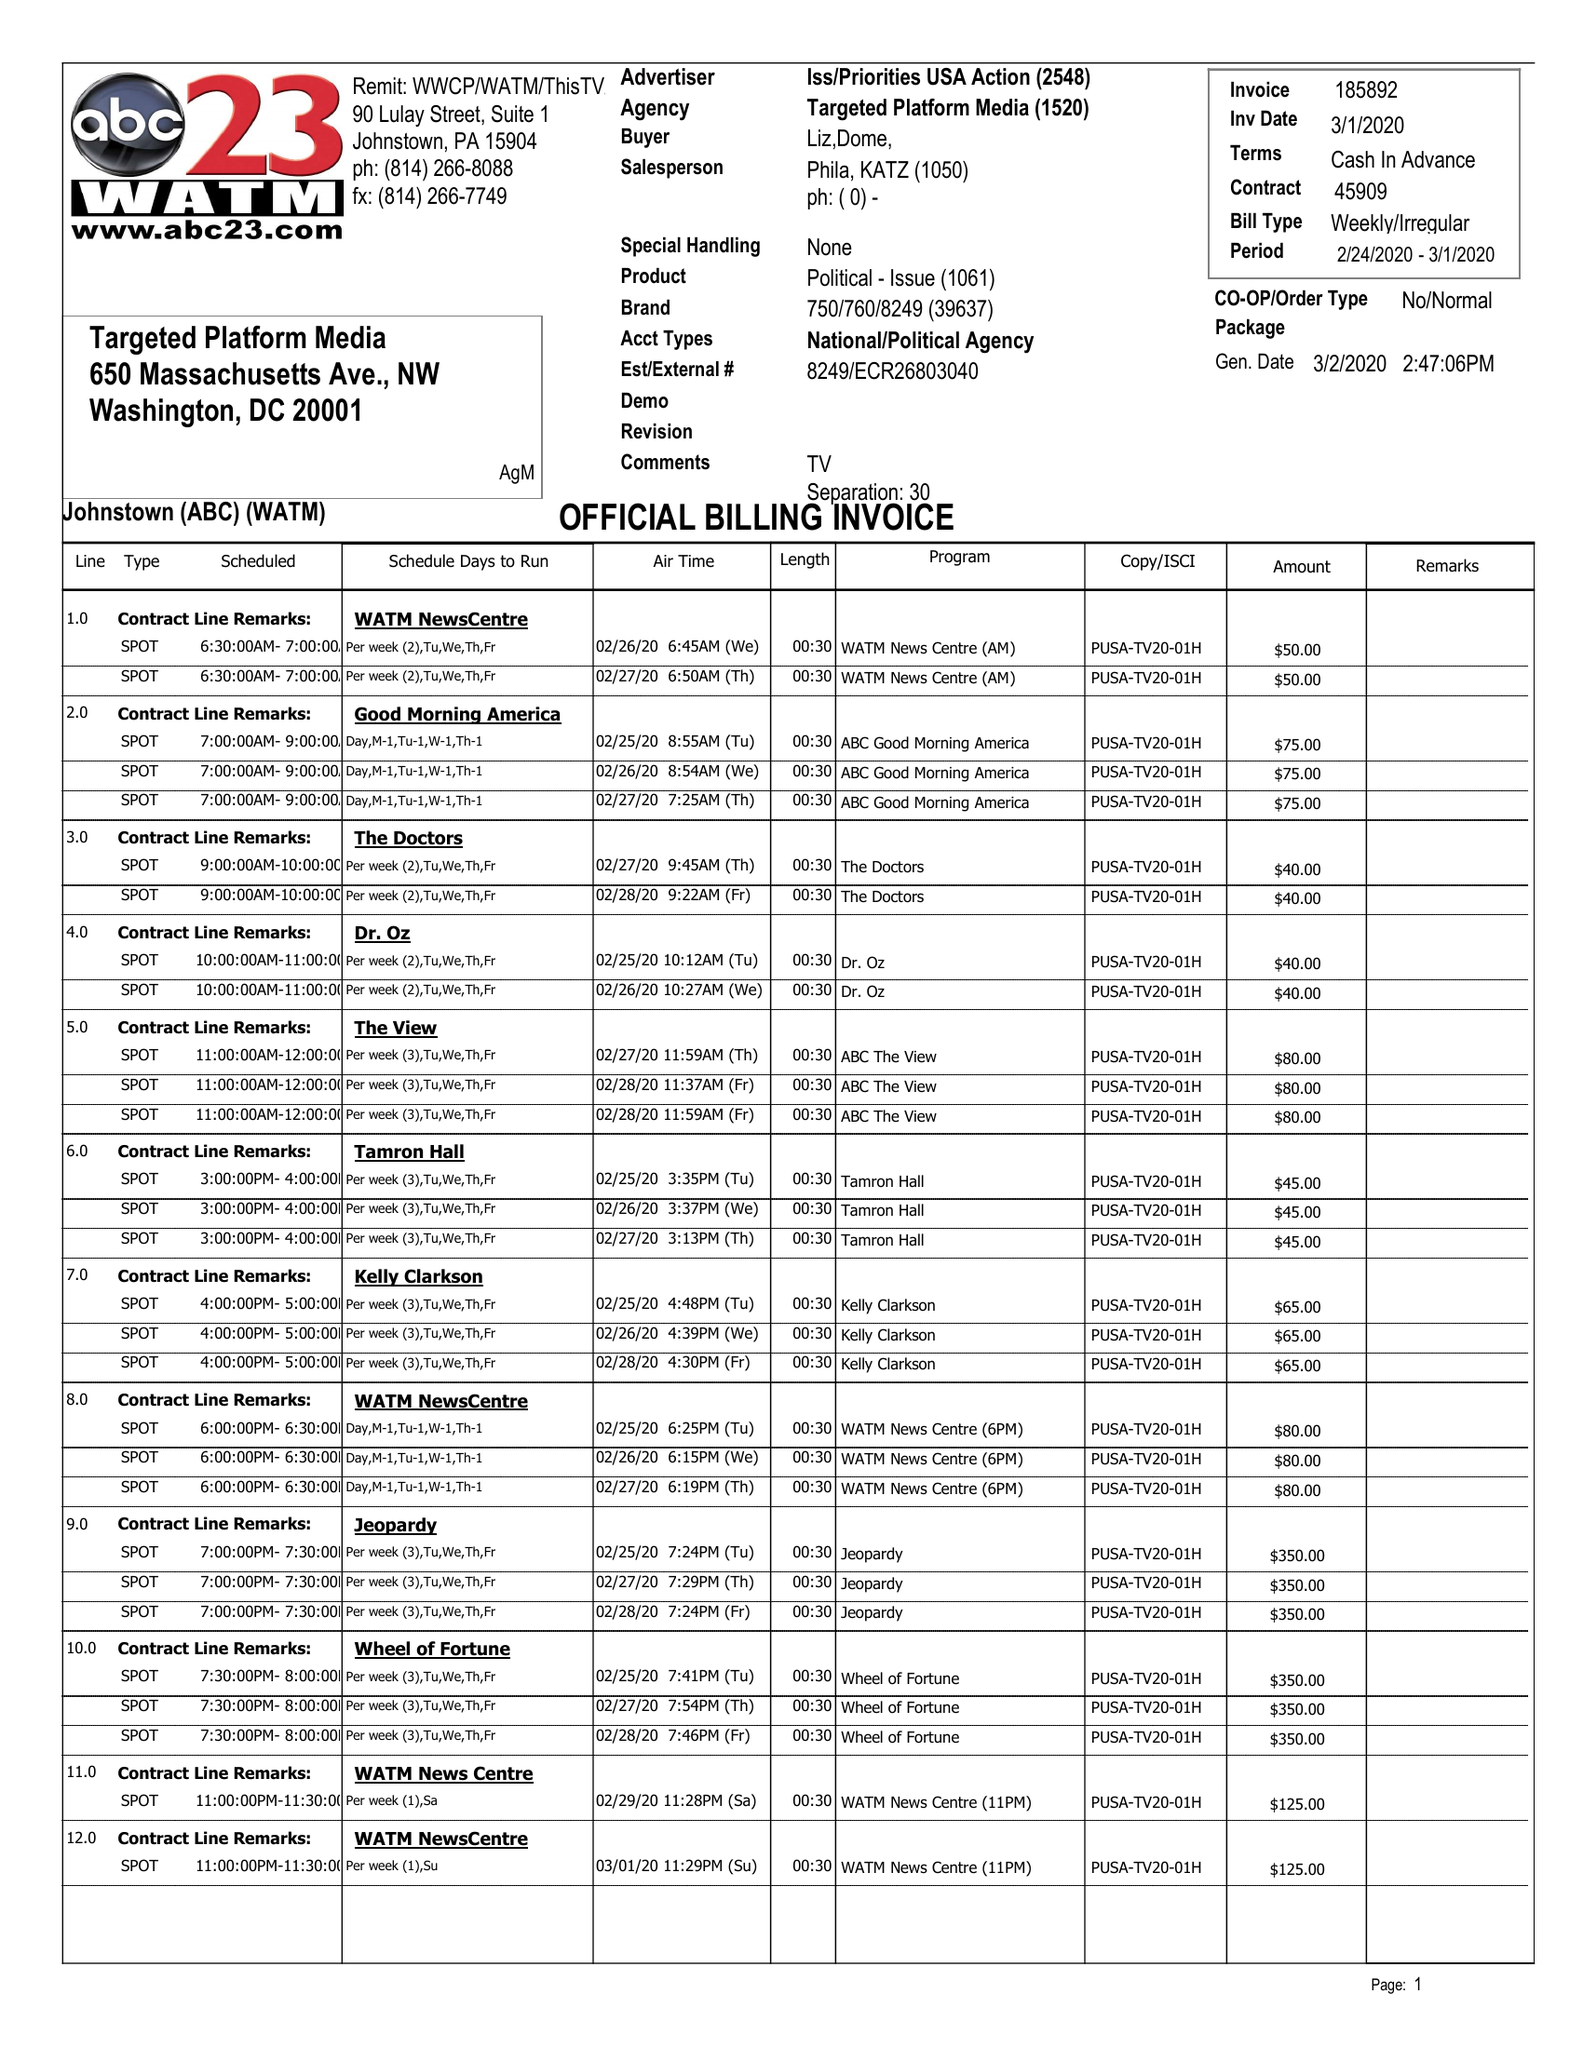What is the value for the flight_from?
Answer the question using a single word or phrase. 02/24/20 